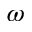<formula> <loc_0><loc_0><loc_500><loc_500>\omega</formula> 